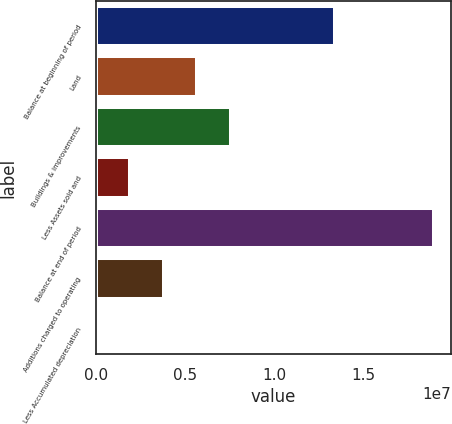Convert chart to OTSL. <chart><loc_0><loc_0><loc_500><loc_500><bar_chart><fcel>Balance at beginning of period<fcel>Land<fcel>Buildings & improvements<fcel>Less Assets sold and<fcel>Balance at end of period<fcel>Additions charged to operating<fcel>Less Accumulated depreciation<nl><fcel>1.34334e+07<fcel>5.70629e+06<fcel>7.60146e+06<fcel>1.91596e+06<fcel>1.89724e+07<fcel>3.81113e+06<fcel>20801<nl></chart> 